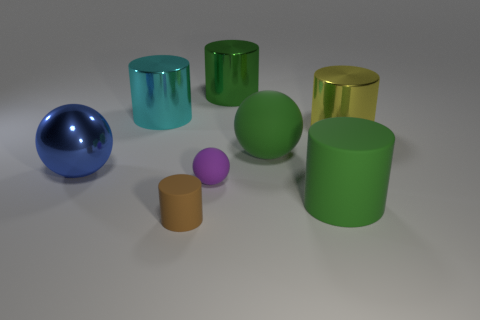The large green matte thing in front of the small ball on the right side of the brown matte cylinder is what shape?
Make the answer very short. Cylinder. There is a green cylinder behind the cyan shiny cylinder; is it the same size as the small brown cylinder?
Provide a succinct answer. No. How big is the cylinder that is behind the tiny brown matte object and on the left side of the big green metal cylinder?
Your response must be concise. Large. What number of other matte things are the same size as the yellow thing?
Offer a very short reply. 2. There is a big cylinder that is to the left of the brown matte thing; what number of shiny cylinders are on the right side of it?
Your response must be concise. 2. There is a big rubber thing that is on the left side of the green matte cylinder; is its color the same as the big matte cylinder?
Your answer should be very brief. Yes. Are there any cylinders right of the thing in front of the green thing in front of the big metal ball?
Keep it short and to the point. Yes. There is a object that is on the left side of the purple thing and to the right of the cyan metal thing; what is its shape?
Make the answer very short. Cylinder. Is there a rubber cylinder of the same color as the large rubber ball?
Keep it short and to the point. Yes. What is the color of the large ball that is left of the cyan cylinder that is to the left of the green matte cylinder?
Provide a short and direct response. Blue. 